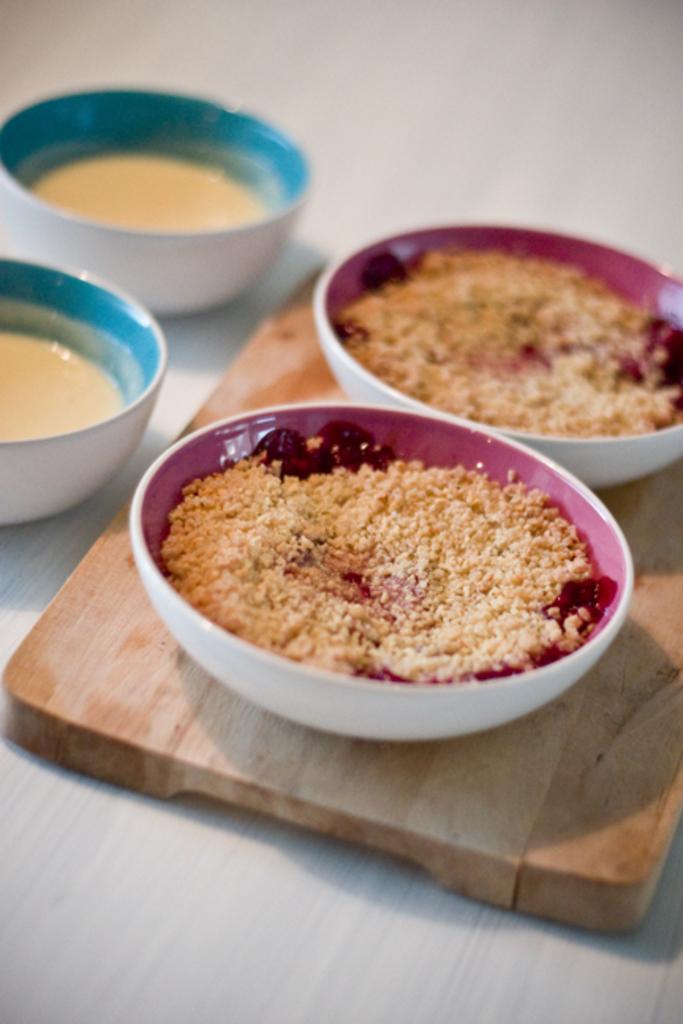Describe this image in one or two sentences. In the image there are two bowls with powder on a wooden block, beside it there are two soup bowls on the table. 